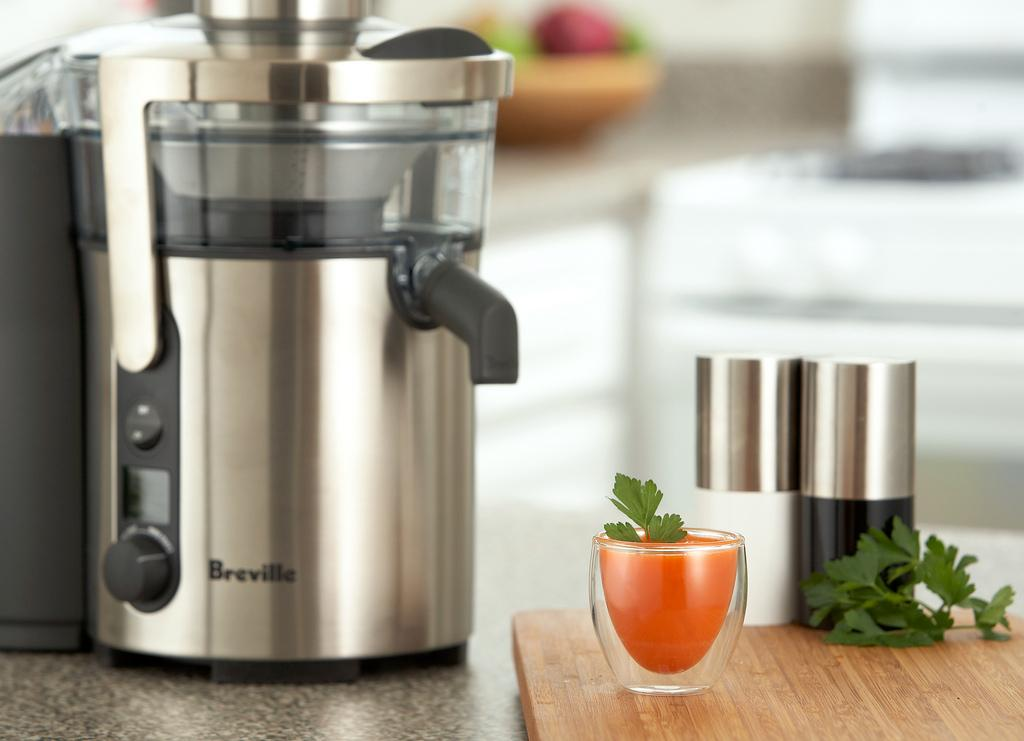<image>
Render a clear and concise summary of the photo. a small electronic device on a counter that says 'breville' on it 